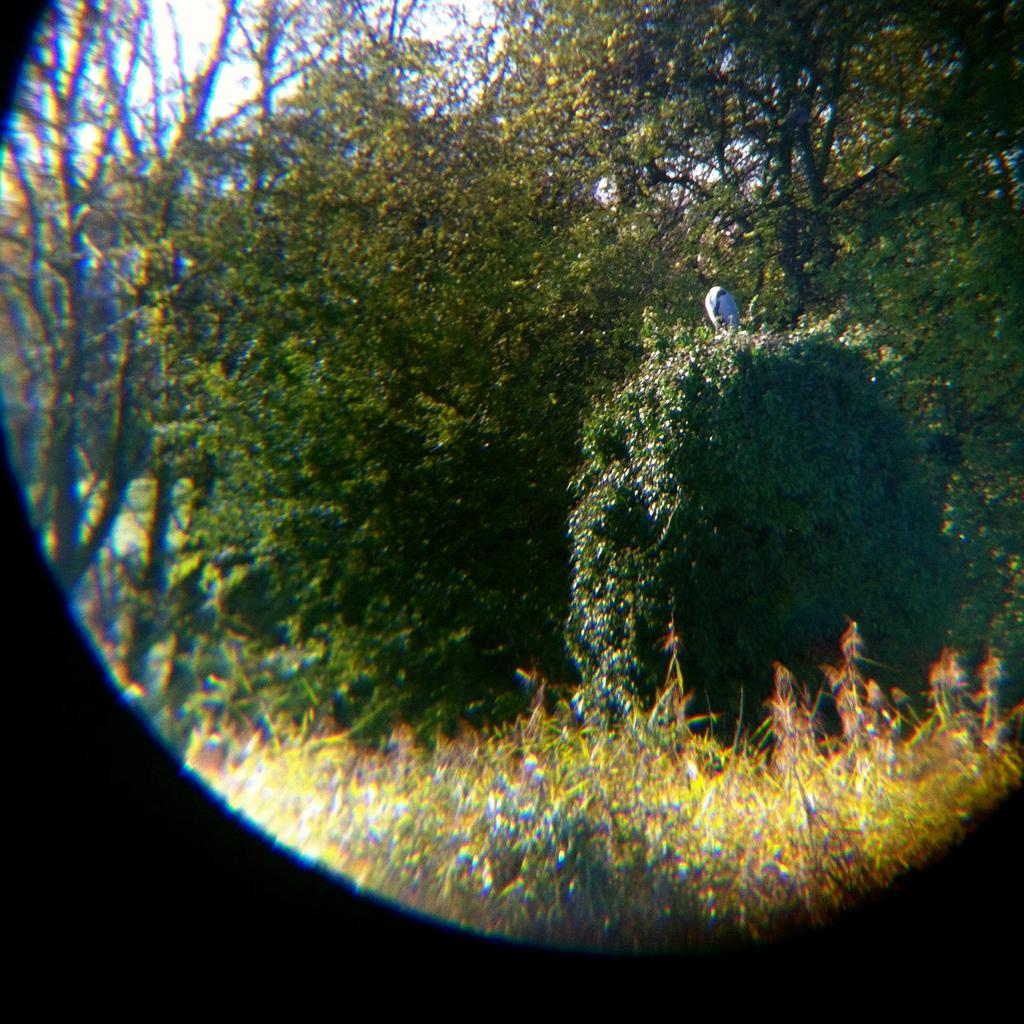What type of vegetation can be seen in the image? There are plants and trees in the image. Where are the plants and trees located? The plants and trees are present on the ground. What type of fruit is hanging from the trees in the image? There is no fruit visible in the image; only plants and trees are present. 